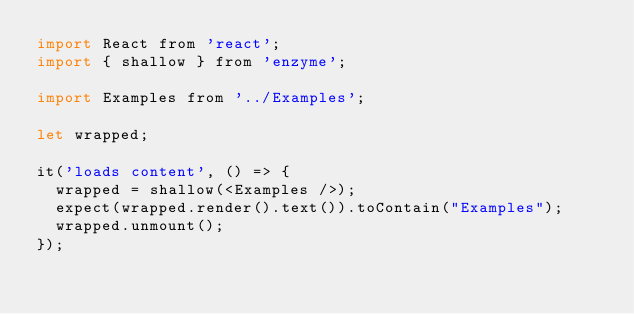<code> <loc_0><loc_0><loc_500><loc_500><_JavaScript_>import React from 'react';
import { shallow } from 'enzyme';

import Examples from '../Examples';

let wrapped;

it('loads content', () => {
  wrapped = shallow(<Examples />);
  expect(wrapped.render().text()).toContain("Examples");
  wrapped.unmount();
});
</code> 